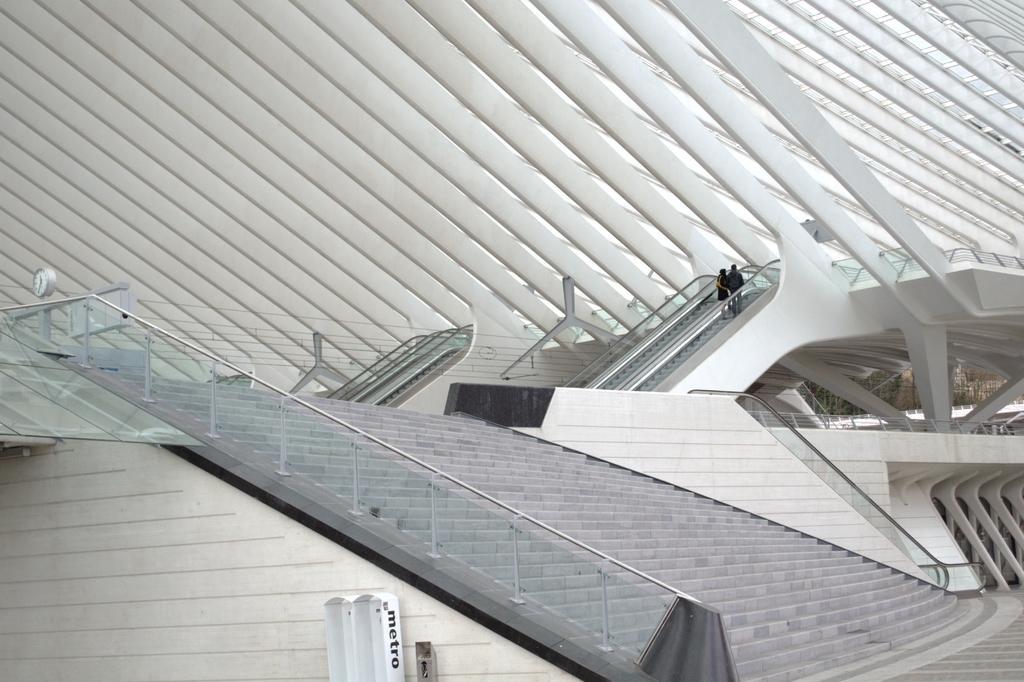Please provide a concise description of this image. In this image we can see steps with glass railings. Also there is a building with pillars and escalators. And there are two persons. 